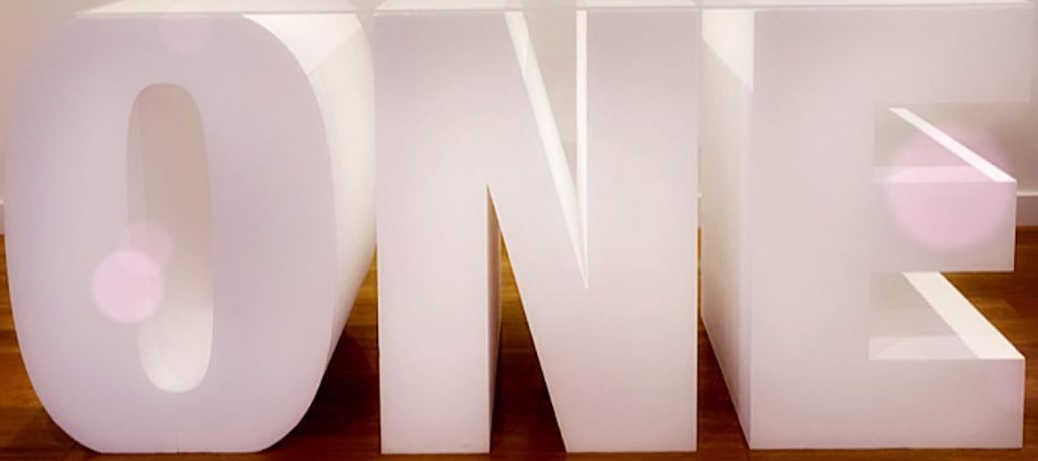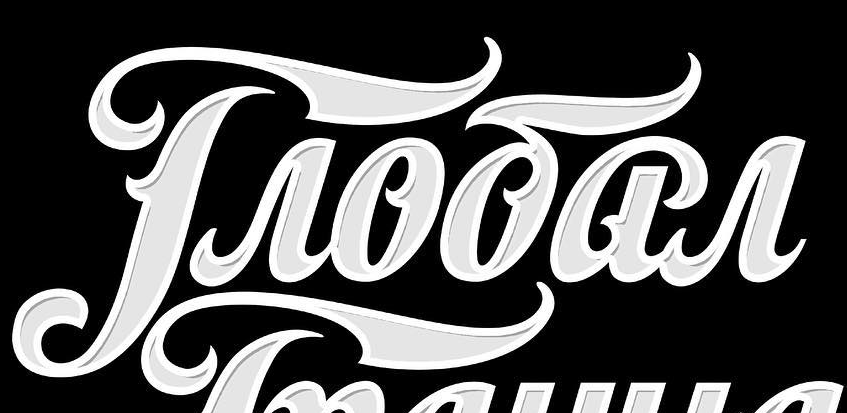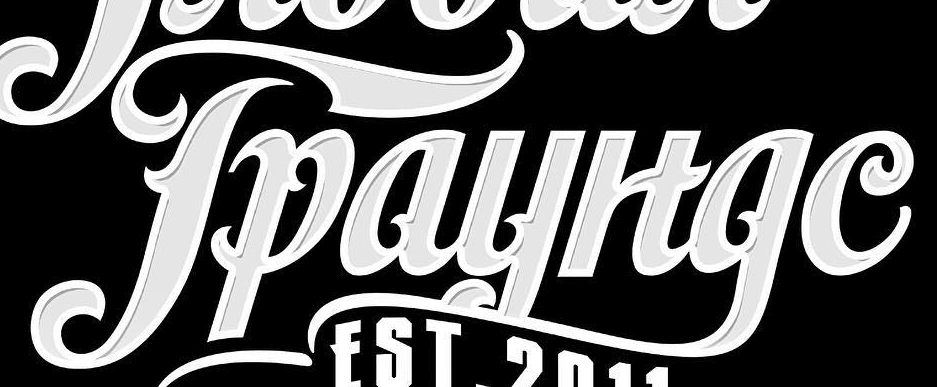What words can you see in these images in sequence, separated by a semicolon? ONE; Troōar; Tpayltge 